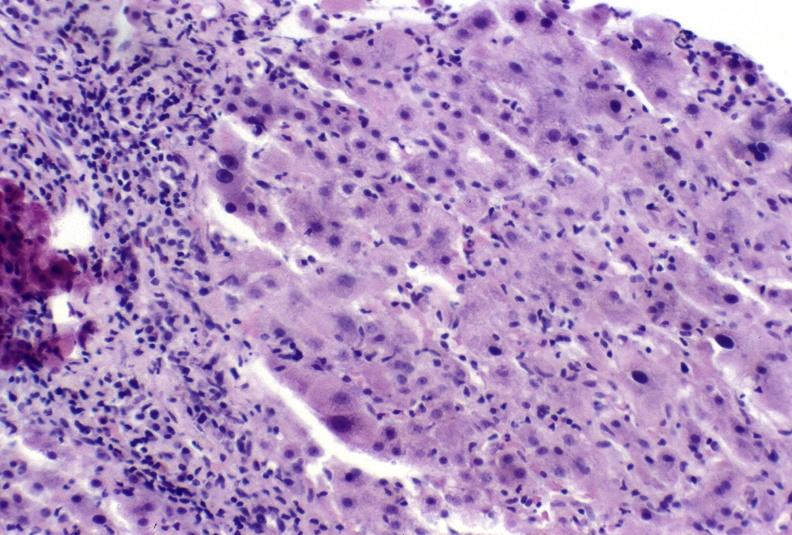s cut present?
Answer the question using a single word or phrase. No 